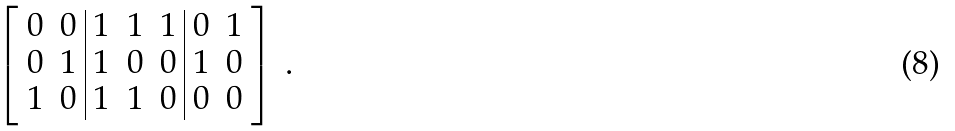<formula> <loc_0><loc_0><loc_500><loc_500>\left [ \begin{array} { c c | c c c | c c } 0 & 0 & 1 & 1 & 1 & 0 & 1 \\ 0 & 1 & 1 & 0 & 0 & 1 & 0 \\ 1 & 0 & 1 & 1 & 0 & 0 & 0 \end{array} \right ] \, .</formula> 